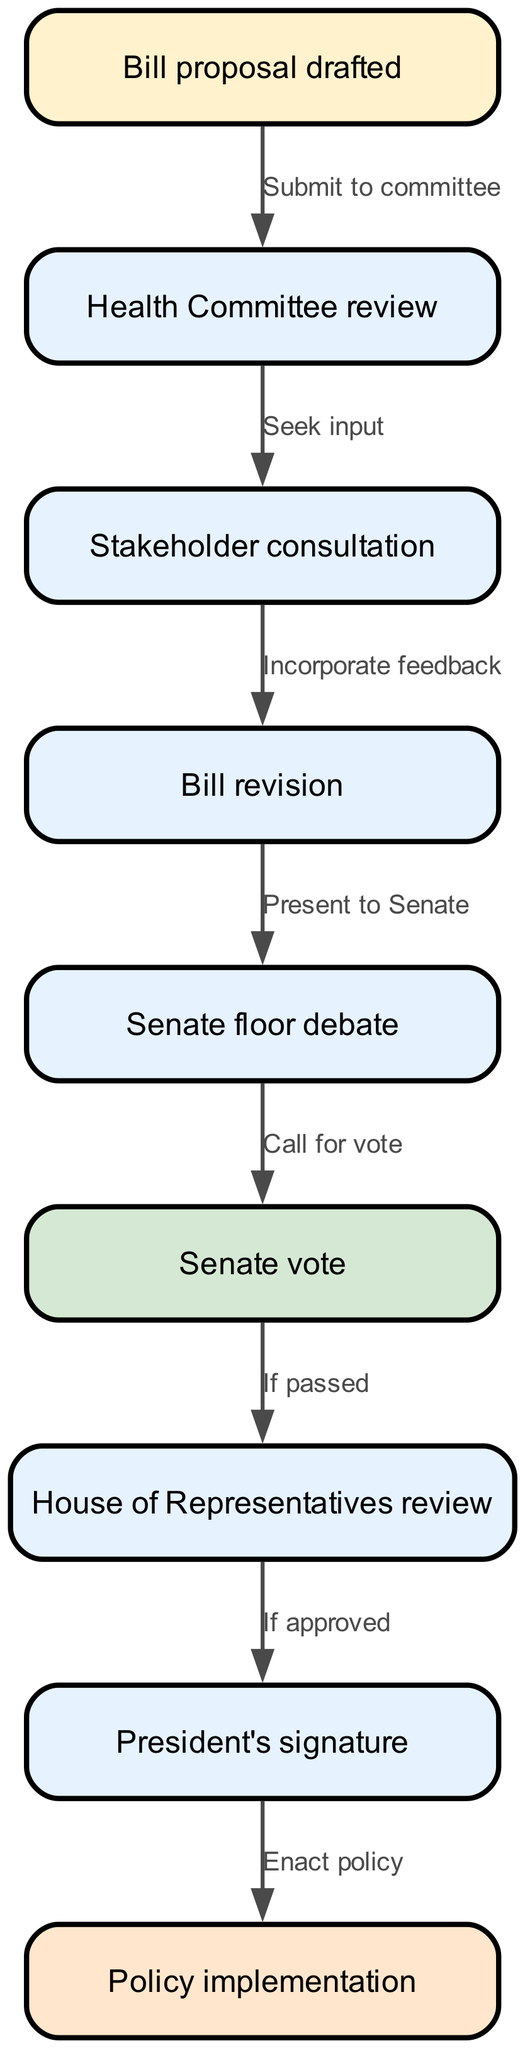What is the first stage of the process? The first stage of the flowchart is represented by the node labeled "Bill proposal drafted." This is where the process begins before any reviews or debates occur.
Answer: Bill proposal drafted How many total nodes are there in the diagram? The diagram includes a total of nine nodes, each representing a different stage in the process of passing a health policy bill.
Answer: 9 What action follows the Senate floor debate? According to the diagram, the action that follows the "Senate floor debate" is to "Call for vote," indicating the transition to the voting stage.
Answer: Call for vote Which stage involves seeking input from external parties? The "Stakeholder consultation" is the stage where input is actively sought from external parties to gather different perspectives on the bill.
Answer: Stakeholder consultation What happens if the bill passes the Senate vote? If the bill passes the Senate vote, it moves to the "House of Representatives review" stage, indicating that it is now considered by another legislative body.
Answer: House of Representatives review What is the final step in the process? The final step in the flowchart is the "Policy implementation," which indicates that the health policy bill is put into effect following all preceding approvals.
Answer: Policy implementation What node indicates the incorporation of feedback into the bill? The node labeled "Bill revision" specifically indicates the stage where feedback collected during the stakeholder consultation process is incorporated into the bill.
Answer: Bill revision What is the relationship between the "House of Representatives review" and the "President's signature"? The relationship indicates that the "House of Representatives review" must result in approval in order to proceed to the "President's signature" stage, which is necessary for the bill to become law.
Answer: If approved During what stage is the bill presented to the Senate? The bill is presented to the Senate during the "Present to Senate" stage, which occurs after revisions have been made.
Answer: Present to Senate 